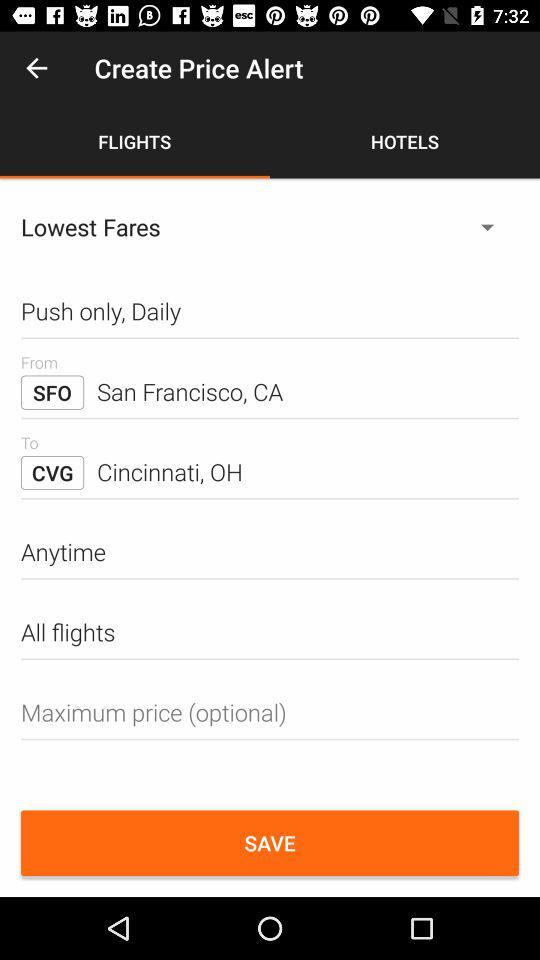From what location will the fare be? The location is "San Francisco, CA". 